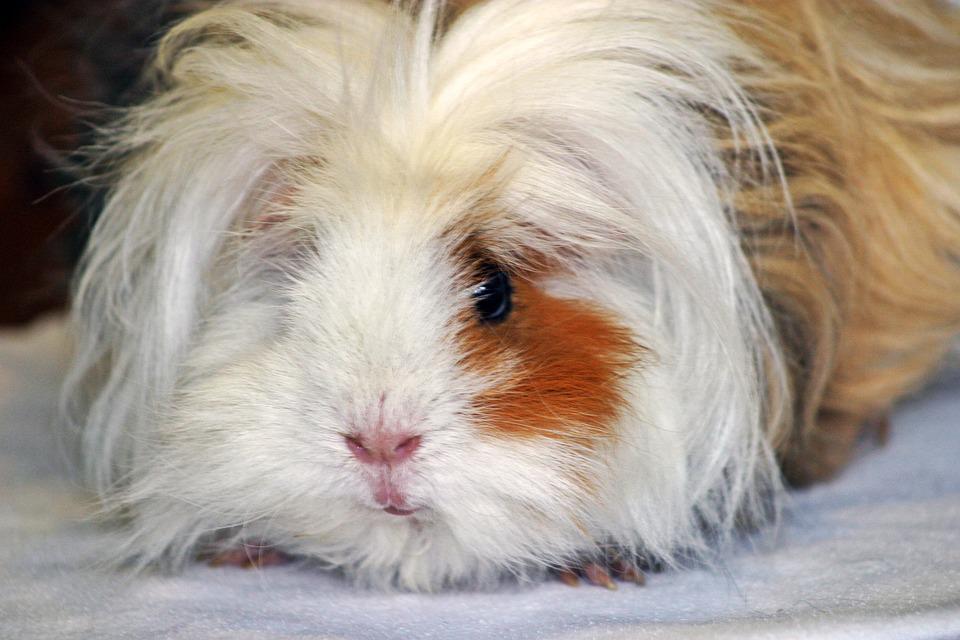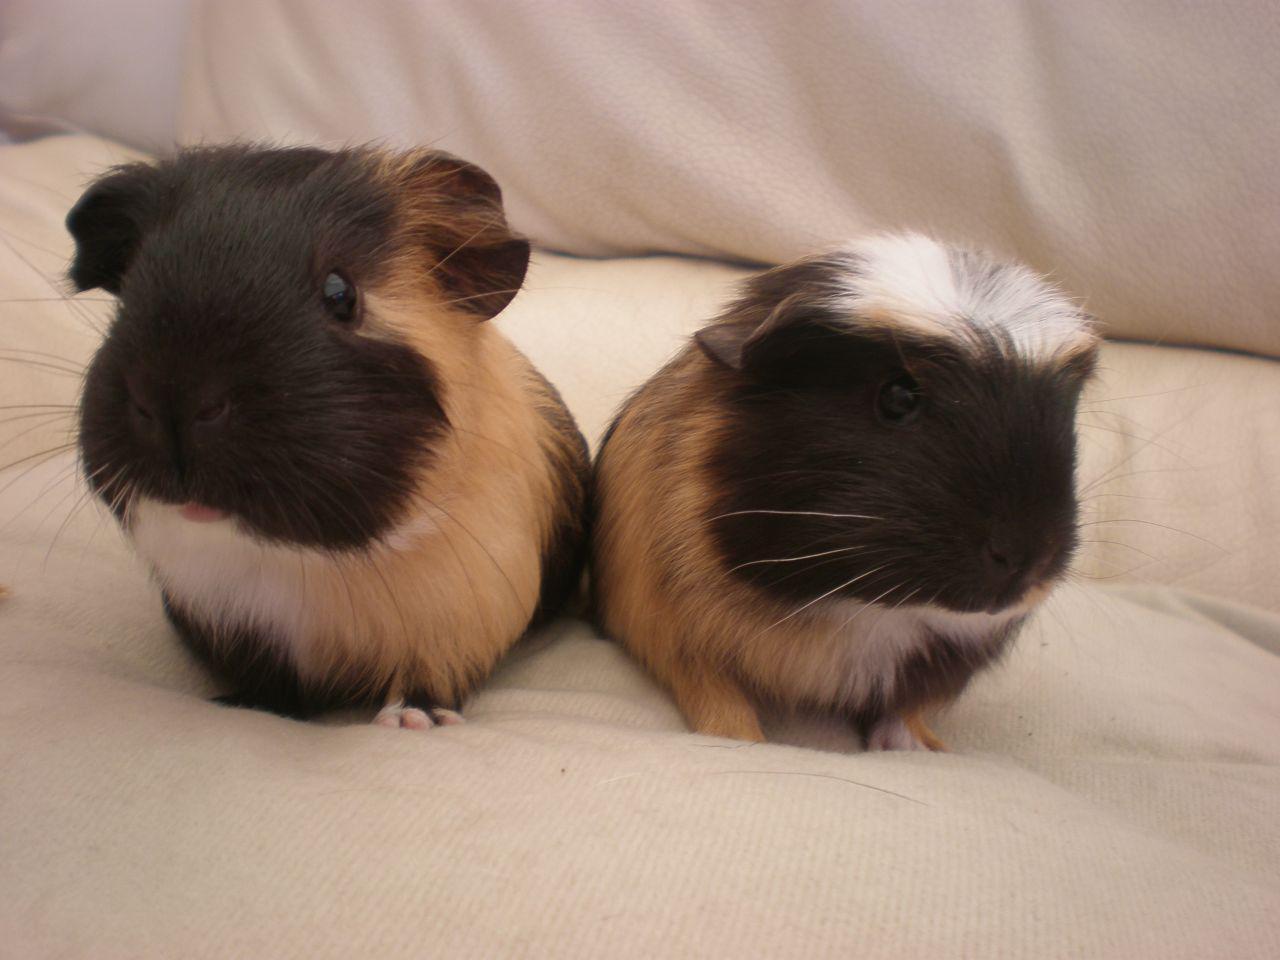The first image is the image on the left, the second image is the image on the right. Assess this claim about the two images: "there is at least one guinea pig in a cardboard box". Correct or not? Answer yes or no. No. The first image is the image on the left, the second image is the image on the right. Evaluate the accuracy of this statement regarding the images: "The right image has two guinea pigs.". Is it true? Answer yes or no. Yes. 